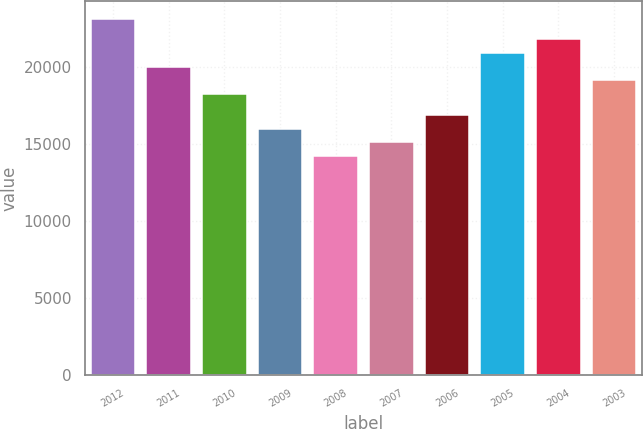Convert chart. <chart><loc_0><loc_0><loc_500><loc_500><bar_chart><fcel>2012<fcel>2011<fcel>2010<fcel>2009<fcel>2008<fcel>2007<fcel>2006<fcel>2005<fcel>2004<fcel>2003<nl><fcel>23096<fcel>19999<fcel>18218<fcel>15972<fcel>14191<fcel>15081.5<fcel>16862.5<fcel>20889.5<fcel>21780<fcel>19108.5<nl></chart> 